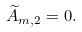Convert formula to latex. <formula><loc_0><loc_0><loc_500><loc_500>\widetilde { A } _ { m , 2 } = 0 .</formula> 